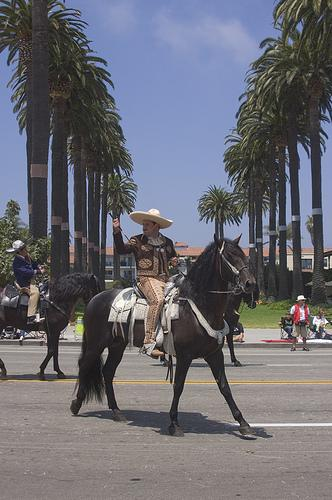What type of hat is the man wearing?

Choices:
A) baseball
B) sombrero
C) fedora
D) tippy sombrero 